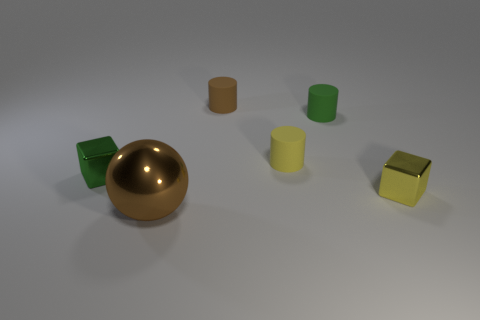Are there any other things that are the same size as the ball?
Make the answer very short. No. What is the material of the brown cylinder?
Keep it short and to the point. Rubber. Do the green cylinder that is on the right side of the ball and the small green block have the same size?
Provide a succinct answer. Yes. There is a metal object that is in front of the small yellow metallic cube; how big is it?
Make the answer very short. Large. How many brown things are there?
Your response must be concise. 2. What color is the tiny thing that is both in front of the brown rubber cylinder and on the left side of the yellow matte cylinder?
Your answer should be very brief. Green. Are there any cylinders in front of the small brown rubber cylinder?
Your answer should be very brief. Yes. There is a green thing on the right side of the large shiny ball; how many yellow objects are behind it?
Your answer should be compact. 0. There is a yellow block that is made of the same material as the big brown thing; what size is it?
Your answer should be compact. Small. The shiny sphere has what size?
Your answer should be compact. Large. 